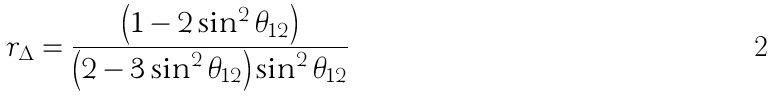<formula> <loc_0><loc_0><loc_500><loc_500>r _ { \Delta } = \frac { \left ( 1 - 2 \sin ^ { 2 } \theta _ { 1 2 } \right ) } { \left ( 2 - 3 \sin ^ { 2 } \theta _ { 1 2 } \right ) \sin ^ { 2 } \theta _ { 1 2 } }</formula> 